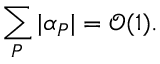<formula> <loc_0><loc_0><loc_500><loc_500>\sum _ { P } | \alpha _ { P } | = \mathcal { O } ( 1 ) .</formula> 